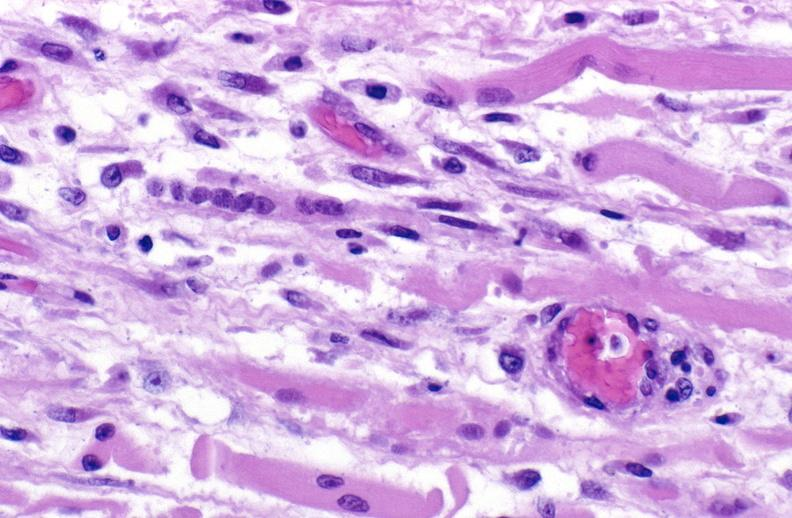s soft tissue present?
Answer the question using a single word or phrase. Yes 